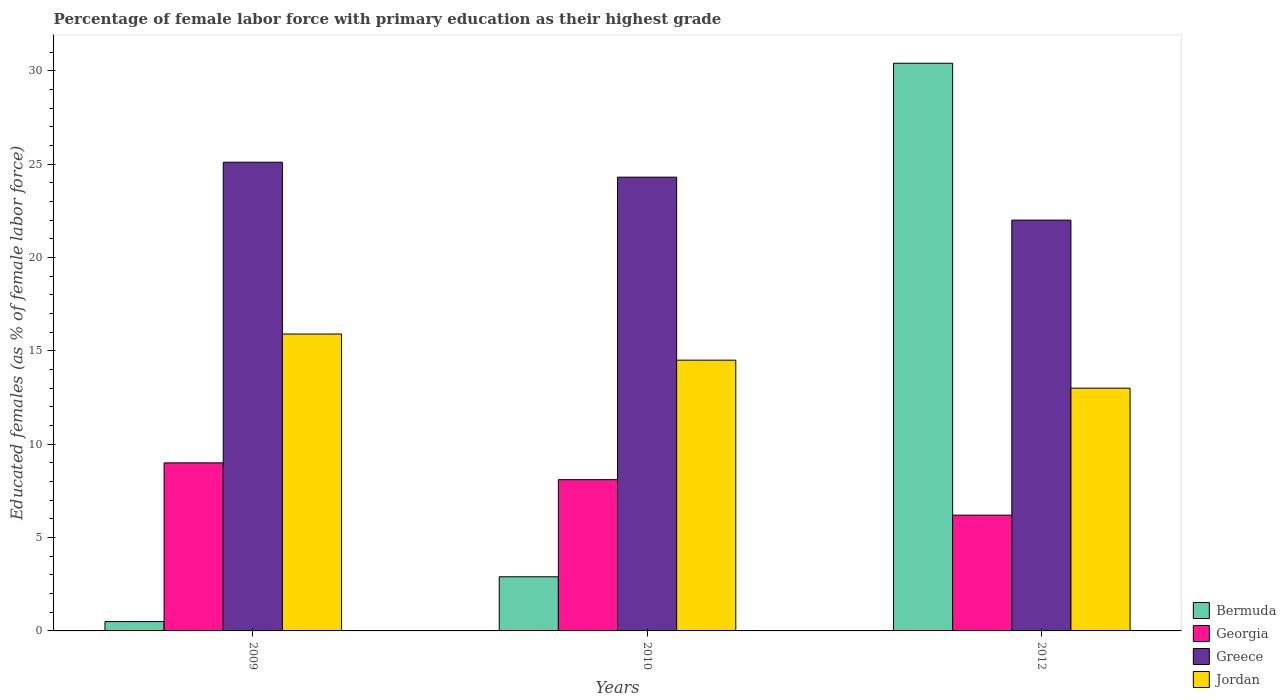How many different coloured bars are there?
Provide a succinct answer. 4. How many groups of bars are there?
Make the answer very short. 3. Are the number of bars per tick equal to the number of legend labels?
Make the answer very short. Yes. How many bars are there on the 3rd tick from the left?
Give a very brief answer. 4. How many bars are there on the 2nd tick from the right?
Your answer should be compact. 4. In how many cases, is the number of bars for a given year not equal to the number of legend labels?
Give a very brief answer. 0. What is the percentage of female labor force with primary education in Bermuda in 2010?
Provide a succinct answer. 2.9. Across all years, what is the maximum percentage of female labor force with primary education in Georgia?
Make the answer very short. 9. In which year was the percentage of female labor force with primary education in Bermuda maximum?
Offer a terse response. 2012. What is the total percentage of female labor force with primary education in Greece in the graph?
Provide a succinct answer. 71.4. What is the difference between the percentage of female labor force with primary education in Georgia in 2009 and that in 2012?
Ensure brevity in your answer.  2.8. What is the difference between the percentage of female labor force with primary education in Georgia in 2010 and the percentage of female labor force with primary education in Bermuda in 2012?
Keep it short and to the point. -22.3. What is the average percentage of female labor force with primary education in Bermuda per year?
Offer a very short reply. 11.27. In how many years, is the percentage of female labor force with primary education in Jordan greater than 19 %?
Make the answer very short. 0. What is the ratio of the percentage of female labor force with primary education in Greece in 2009 to that in 2010?
Keep it short and to the point. 1.03. What is the difference between the highest and the second highest percentage of female labor force with primary education in Jordan?
Make the answer very short. 1.4. What is the difference between the highest and the lowest percentage of female labor force with primary education in Jordan?
Provide a succinct answer. 2.9. Is the sum of the percentage of female labor force with primary education in Jordan in 2009 and 2010 greater than the maximum percentage of female labor force with primary education in Bermuda across all years?
Give a very brief answer. No. Is it the case that in every year, the sum of the percentage of female labor force with primary education in Georgia and percentage of female labor force with primary education in Jordan is greater than the sum of percentage of female labor force with primary education in Greece and percentage of female labor force with primary education in Bermuda?
Ensure brevity in your answer.  Yes. What does the 4th bar from the right in 2009 represents?
Offer a very short reply. Bermuda. Is it the case that in every year, the sum of the percentage of female labor force with primary education in Bermuda and percentage of female labor force with primary education in Jordan is greater than the percentage of female labor force with primary education in Georgia?
Provide a succinct answer. Yes. Are all the bars in the graph horizontal?
Offer a terse response. No. How many years are there in the graph?
Make the answer very short. 3. What is the difference between two consecutive major ticks on the Y-axis?
Provide a short and direct response. 5. Are the values on the major ticks of Y-axis written in scientific E-notation?
Provide a short and direct response. No. Where does the legend appear in the graph?
Keep it short and to the point. Bottom right. How many legend labels are there?
Your answer should be very brief. 4. What is the title of the graph?
Offer a terse response. Percentage of female labor force with primary education as their highest grade. Does "Zimbabwe" appear as one of the legend labels in the graph?
Make the answer very short. No. What is the label or title of the X-axis?
Your response must be concise. Years. What is the label or title of the Y-axis?
Offer a very short reply. Educated females (as % of female labor force). What is the Educated females (as % of female labor force) in Georgia in 2009?
Keep it short and to the point. 9. What is the Educated females (as % of female labor force) in Greece in 2009?
Offer a very short reply. 25.1. What is the Educated females (as % of female labor force) in Jordan in 2009?
Provide a succinct answer. 15.9. What is the Educated females (as % of female labor force) in Bermuda in 2010?
Keep it short and to the point. 2.9. What is the Educated females (as % of female labor force) in Georgia in 2010?
Offer a terse response. 8.1. What is the Educated females (as % of female labor force) in Greece in 2010?
Your answer should be compact. 24.3. What is the Educated females (as % of female labor force) of Bermuda in 2012?
Offer a terse response. 30.4. What is the Educated females (as % of female labor force) of Georgia in 2012?
Keep it short and to the point. 6.2. What is the Educated females (as % of female labor force) of Jordan in 2012?
Make the answer very short. 13. Across all years, what is the maximum Educated females (as % of female labor force) in Bermuda?
Your answer should be compact. 30.4. Across all years, what is the maximum Educated females (as % of female labor force) of Greece?
Your answer should be very brief. 25.1. Across all years, what is the maximum Educated females (as % of female labor force) in Jordan?
Ensure brevity in your answer.  15.9. Across all years, what is the minimum Educated females (as % of female labor force) in Bermuda?
Your answer should be very brief. 0.5. Across all years, what is the minimum Educated females (as % of female labor force) in Georgia?
Keep it short and to the point. 6.2. Across all years, what is the minimum Educated females (as % of female labor force) of Jordan?
Your answer should be very brief. 13. What is the total Educated females (as % of female labor force) in Bermuda in the graph?
Provide a succinct answer. 33.8. What is the total Educated females (as % of female labor force) in Georgia in the graph?
Offer a terse response. 23.3. What is the total Educated females (as % of female labor force) of Greece in the graph?
Your answer should be very brief. 71.4. What is the total Educated females (as % of female labor force) of Jordan in the graph?
Your response must be concise. 43.4. What is the difference between the Educated females (as % of female labor force) in Bermuda in 2009 and that in 2010?
Give a very brief answer. -2.4. What is the difference between the Educated females (as % of female labor force) of Greece in 2009 and that in 2010?
Keep it short and to the point. 0.8. What is the difference between the Educated females (as % of female labor force) of Jordan in 2009 and that in 2010?
Your answer should be very brief. 1.4. What is the difference between the Educated females (as % of female labor force) in Bermuda in 2009 and that in 2012?
Keep it short and to the point. -29.9. What is the difference between the Educated females (as % of female labor force) of Georgia in 2009 and that in 2012?
Offer a very short reply. 2.8. What is the difference between the Educated females (as % of female labor force) of Jordan in 2009 and that in 2012?
Provide a short and direct response. 2.9. What is the difference between the Educated females (as % of female labor force) of Bermuda in 2010 and that in 2012?
Offer a very short reply. -27.5. What is the difference between the Educated females (as % of female labor force) in Bermuda in 2009 and the Educated females (as % of female labor force) in Greece in 2010?
Give a very brief answer. -23.8. What is the difference between the Educated females (as % of female labor force) in Georgia in 2009 and the Educated females (as % of female labor force) in Greece in 2010?
Ensure brevity in your answer.  -15.3. What is the difference between the Educated females (as % of female labor force) of Bermuda in 2009 and the Educated females (as % of female labor force) of Greece in 2012?
Offer a terse response. -21.5. What is the difference between the Educated females (as % of female labor force) of Bermuda in 2009 and the Educated females (as % of female labor force) of Jordan in 2012?
Offer a very short reply. -12.5. What is the difference between the Educated females (as % of female labor force) of Georgia in 2009 and the Educated females (as % of female labor force) of Greece in 2012?
Provide a short and direct response. -13. What is the difference between the Educated females (as % of female labor force) of Greece in 2009 and the Educated females (as % of female labor force) of Jordan in 2012?
Offer a terse response. 12.1. What is the difference between the Educated females (as % of female labor force) in Bermuda in 2010 and the Educated females (as % of female labor force) in Georgia in 2012?
Your response must be concise. -3.3. What is the difference between the Educated females (as % of female labor force) in Bermuda in 2010 and the Educated females (as % of female labor force) in Greece in 2012?
Offer a terse response. -19.1. What is the difference between the Educated females (as % of female labor force) of Bermuda in 2010 and the Educated females (as % of female labor force) of Jordan in 2012?
Your answer should be compact. -10.1. What is the difference between the Educated females (as % of female labor force) in Greece in 2010 and the Educated females (as % of female labor force) in Jordan in 2012?
Give a very brief answer. 11.3. What is the average Educated females (as % of female labor force) in Bermuda per year?
Make the answer very short. 11.27. What is the average Educated females (as % of female labor force) in Georgia per year?
Give a very brief answer. 7.77. What is the average Educated females (as % of female labor force) in Greece per year?
Your response must be concise. 23.8. What is the average Educated females (as % of female labor force) in Jordan per year?
Offer a terse response. 14.47. In the year 2009, what is the difference between the Educated females (as % of female labor force) in Bermuda and Educated females (as % of female labor force) in Georgia?
Provide a succinct answer. -8.5. In the year 2009, what is the difference between the Educated females (as % of female labor force) in Bermuda and Educated females (as % of female labor force) in Greece?
Ensure brevity in your answer.  -24.6. In the year 2009, what is the difference between the Educated females (as % of female labor force) of Bermuda and Educated females (as % of female labor force) of Jordan?
Your response must be concise. -15.4. In the year 2009, what is the difference between the Educated females (as % of female labor force) of Georgia and Educated females (as % of female labor force) of Greece?
Keep it short and to the point. -16.1. In the year 2009, what is the difference between the Educated females (as % of female labor force) in Georgia and Educated females (as % of female labor force) in Jordan?
Offer a terse response. -6.9. In the year 2009, what is the difference between the Educated females (as % of female labor force) of Greece and Educated females (as % of female labor force) of Jordan?
Provide a short and direct response. 9.2. In the year 2010, what is the difference between the Educated females (as % of female labor force) in Bermuda and Educated females (as % of female labor force) in Georgia?
Offer a very short reply. -5.2. In the year 2010, what is the difference between the Educated females (as % of female labor force) in Bermuda and Educated females (as % of female labor force) in Greece?
Make the answer very short. -21.4. In the year 2010, what is the difference between the Educated females (as % of female labor force) in Bermuda and Educated females (as % of female labor force) in Jordan?
Provide a succinct answer. -11.6. In the year 2010, what is the difference between the Educated females (as % of female labor force) of Georgia and Educated females (as % of female labor force) of Greece?
Offer a very short reply. -16.2. In the year 2010, what is the difference between the Educated females (as % of female labor force) in Georgia and Educated females (as % of female labor force) in Jordan?
Keep it short and to the point. -6.4. In the year 2012, what is the difference between the Educated females (as % of female labor force) in Bermuda and Educated females (as % of female labor force) in Georgia?
Your answer should be compact. 24.2. In the year 2012, what is the difference between the Educated females (as % of female labor force) of Bermuda and Educated females (as % of female labor force) of Greece?
Your response must be concise. 8.4. In the year 2012, what is the difference between the Educated females (as % of female labor force) in Bermuda and Educated females (as % of female labor force) in Jordan?
Your answer should be very brief. 17.4. In the year 2012, what is the difference between the Educated females (as % of female labor force) in Georgia and Educated females (as % of female labor force) in Greece?
Your answer should be very brief. -15.8. In the year 2012, what is the difference between the Educated females (as % of female labor force) in Greece and Educated females (as % of female labor force) in Jordan?
Your response must be concise. 9. What is the ratio of the Educated females (as % of female labor force) of Bermuda in 2009 to that in 2010?
Give a very brief answer. 0.17. What is the ratio of the Educated females (as % of female labor force) in Greece in 2009 to that in 2010?
Provide a short and direct response. 1.03. What is the ratio of the Educated females (as % of female labor force) of Jordan in 2009 to that in 2010?
Make the answer very short. 1.1. What is the ratio of the Educated females (as % of female labor force) of Bermuda in 2009 to that in 2012?
Provide a short and direct response. 0.02. What is the ratio of the Educated females (as % of female labor force) of Georgia in 2009 to that in 2012?
Make the answer very short. 1.45. What is the ratio of the Educated females (as % of female labor force) of Greece in 2009 to that in 2012?
Offer a terse response. 1.14. What is the ratio of the Educated females (as % of female labor force) of Jordan in 2009 to that in 2012?
Provide a short and direct response. 1.22. What is the ratio of the Educated females (as % of female labor force) of Bermuda in 2010 to that in 2012?
Provide a short and direct response. 0.1. What is the ratio of the Educated females (as % of female labor force) of Georgia in 2010 to that in 2012?
Your answer should be very brief. 1.31. What is the ratio of the Educated females (as % of female labor force) in Greece in 2010 to that in 2012?
Ensure brevity in your answer.  1.1. What is the ratio of the Educated females (as % of female labor force) of Jordan in 2010 to that in 2012?
Give a very brief answer. 1.12. What is the difference between the highest and the second highest Educated females (as % of female labor force) in Bermuda?
Your answer should be compact. 27.5. What is the difference between the highest and the lowest Educated females (as % of female labor force) of Bermuda?
Provide a short and direct response. 29.9. What is the difference between the highest and the lowest Educated females (as % of female labor force) in Greece?
Make the answer very short. 3.1. What is the difference between the highest and the lowest Educated females (as % of female labor force) of Jordan?
Your response must be concise. 2.9. 